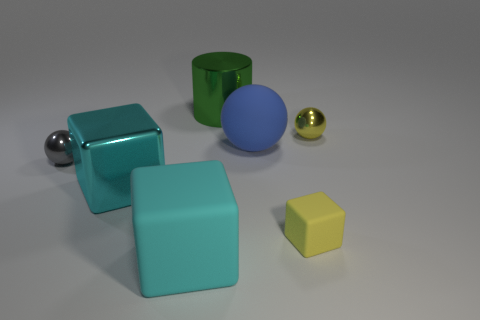Subtract all purple spheres. How many cyan cubes are left? 2 Add 1 yellow things. How many objects exist? 8 Subtract all cylinders. How many objects are left? 6 Subtract all large red metal blocks. Subtract all cyan metallic cubes. How many objects are left? 6 Add 3 blue spheres. How many blue spheres are left? 4 Add 1 blue rubber cubes. How many blue rubber cubes exist? 1 Subtract 0 red spheres. How many objects are left? 7 